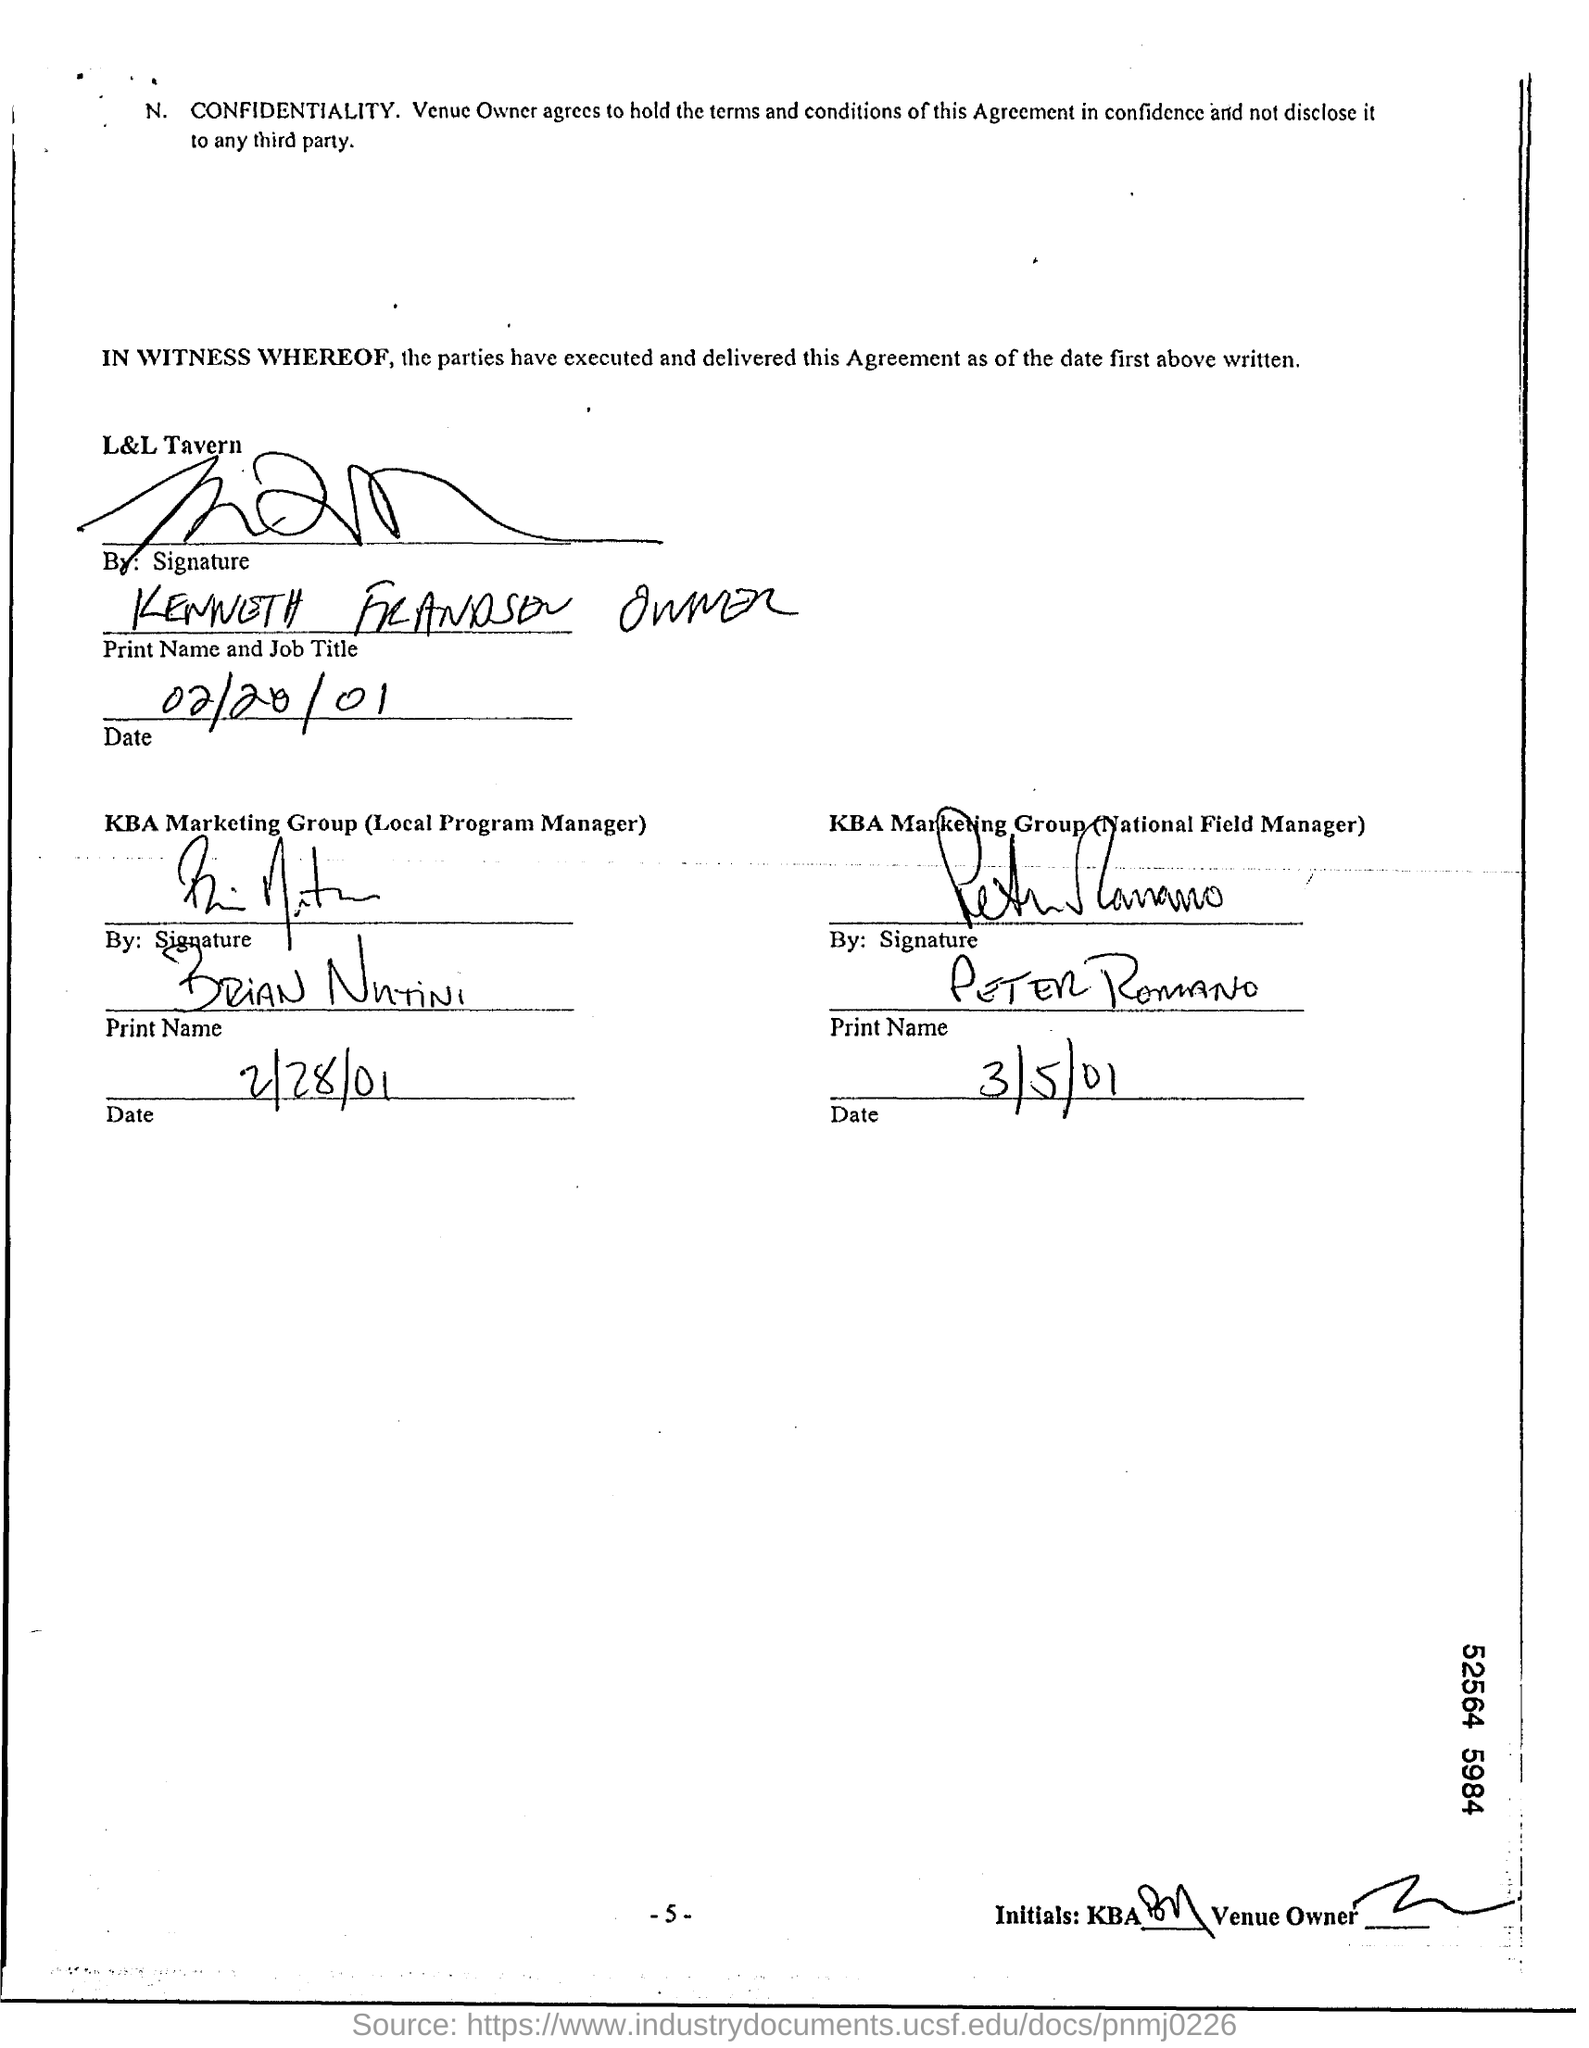What is the date written for L&L Tavern?
 02/20/01 